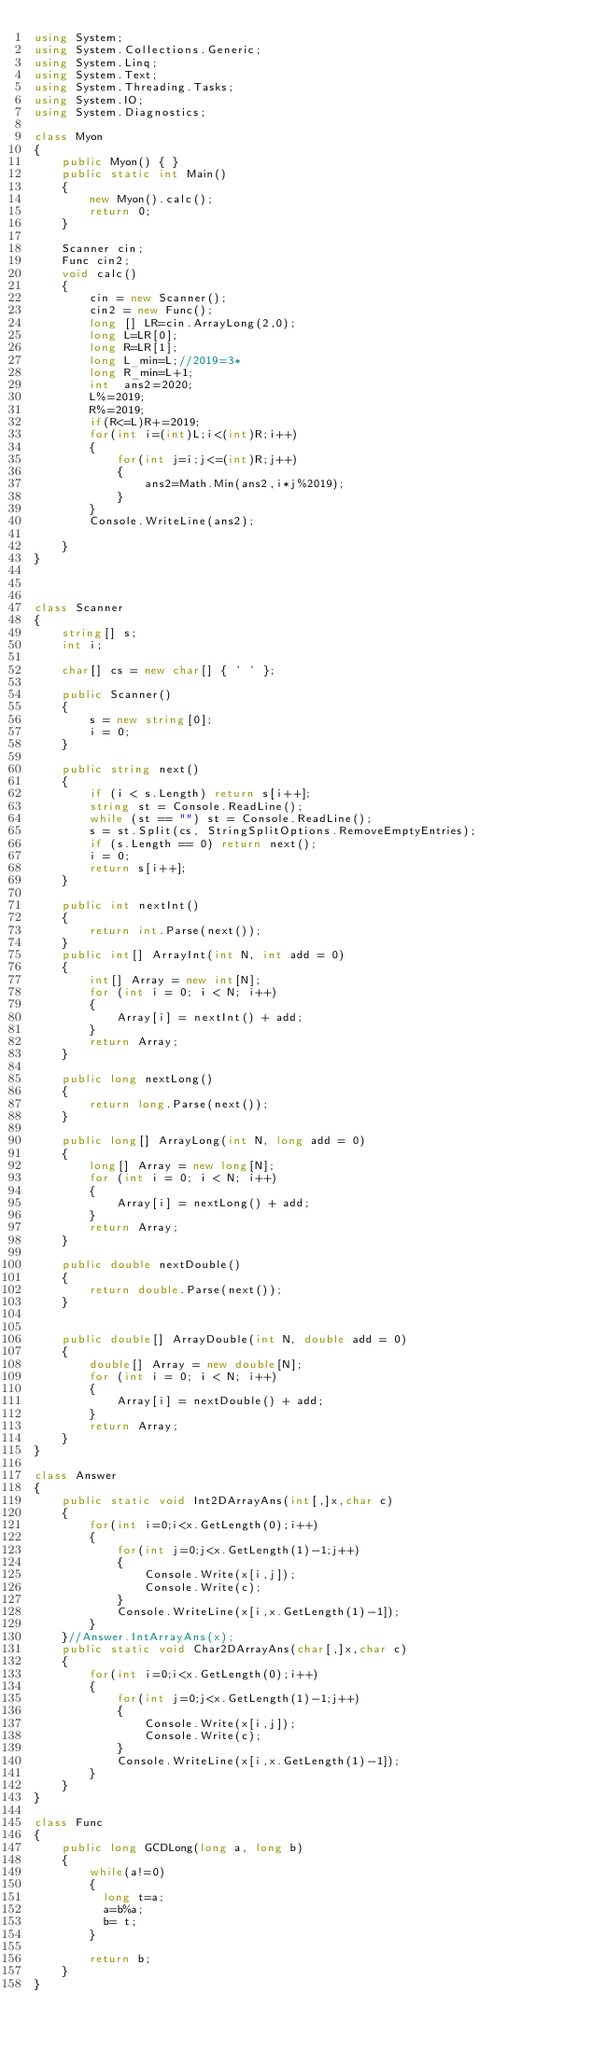<code> <loc_0><loc_0><loc_500><loc_500><_C#_>using System;
using System.Collections.Generic;
using System.Linq;
using System.Text;
using System.Threading.Tasks;
using System.IO;
using System.Diagnostics;

class Myon
{
    public Myon() { }
    public static int Main()
    {
        new Myon().calc();
        return 0;
    }

    Scanner cin;
    Func cin2;
    void calc()
    {
        cin = new Scanner();
        cin2 = new Func();
        long [] LR=cin.ArrayLong(2,0);
        long L=LR[0];
        long R=LR[1];
        long L_min=L;//2019=3*
        long R_min=L+1;
        int  ans2=2020;
        L%=2019;
        R%=2019;
        if(R<=L)R+=2019;
        for(int i=(int)L;i<(int)R;i++)
        {
            for(int j=i;j<=(int)R;j++)
            {
                ans2=Math.Min(ans2,i*j%2019);
            }
        }
        Console.WriteLine(ans2);
        
    }
}



class Scanner
{
    string[] s;
    int i;

    char[] cs = new char[] { ' ' };

    public Scanner()
    {
        s = new string[0];
        i = 0;
    }

    public string next()
    {
        if (i < s.Length) return s[i++];
        string st = Console.ReadLine();
        while (st == "") st = Console.ReadLine();
        s = st.Split(cs, StringSplitOptions.RemoveEmptyEntries);
        if (s.Length == 0) return next();
        i = 0;
        return s[i++];
    }

    public int nextInt()
    {
        return int.Parse(next());
    }
    public int[] ArrayInt(int N, int add = 0)
    {
        int[] Array = new int[N];
        for (int i = 0; i < N; i++)
        {
            Array[i] = nextInt() + add;
        }
        return Array;
    }

    public long nextLong()
    {
        return long.Parse(next());
    }

    public long[] ArrayLong(int N, long add = 0)
    {
        long[] Array = new long[N];
        for (int i = 0; i < N; i++)
        {
            Array[i] = nextLong() + add;
        }
        return Array;
    }

    public double nextDouble()
    {
        return double.Parse(next());
    }


    public double[] ArrayDouble(int N, double add = 0)
    {
        double[] Array = new double[N];
        for (int i = 0; i < N; i++)
        {
            Array[i] = nextDouble() + add;
        }
        return Array;
    }
}

class Answer
{
    public static void Int2DArrayAns(int[,]x,char c)
    {
        for(int i=0;i<x.GetLength(0);i++)
        {
            for(int j=0;j<x.GetLength(1)-1;j++)
            {
                Console.Write(x[i,j]);
                Console.Write(c);
            }
            Console.WriteLine(x[i,x.GetLength(1)-1]);
        }
    }//Answer.IntArrayAns(x);
    public static void Char2DArrayAns(char[,]x,char c)
    {
        for(int i=0;i<x.GetLength(0);i++)
        {
            for(int j=0;j<x.GetLength(1)-1;j++)
            {
                Console.Write(x[i,j]);
                Console.Write(c);
            }
            Console.WriteLine(x[i,x.GetLength(1)-1]);
        }
    }
}

class Func
{
    public long GCDLong(long a, long b)
    {
        while(a!=0)
        {
          long t=a;
          a=b%a;
          b= t;
        }
      
        return b;        
    }
}
</code> 